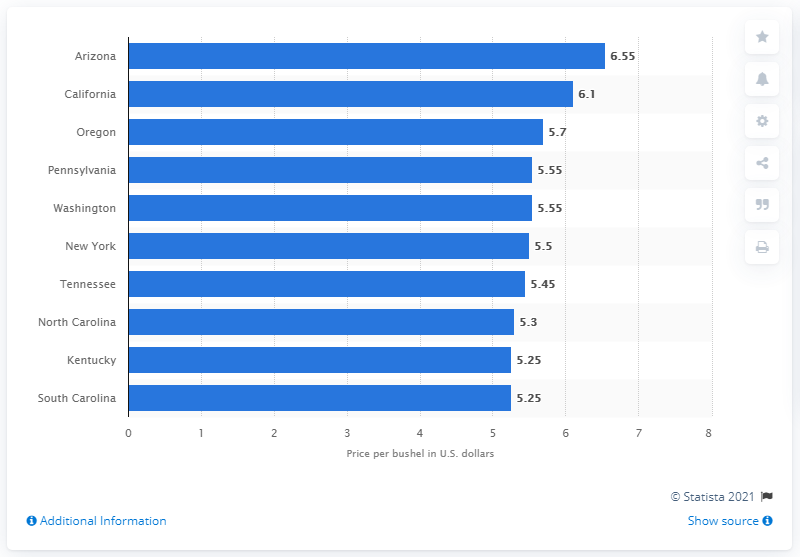What was Arizona's average price per bushel of wheat?
 6.55 